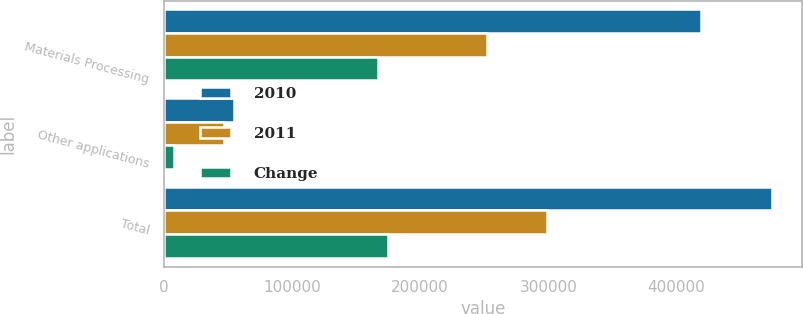Convert chart to OTSL. <chart><loc_0><loc_0><loc_500><loc_500><stacked_bar_chart><ecel><fcel>Materials Processing<fcel>Other applications<fcel>Total<nl><fcel>2010<fcel>419443<fcel>55039<fcel>474482<nl><fcel>2011<fcel>252014<fcel>47242<fcel>299256<nl><fcel>Change<fcel>167429<fcel>7797<fcel>175226<nl></chart> 